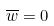<formula> <loc_0><loc_0><loc_500><loc_500>\overline { w } = 0</formula> 